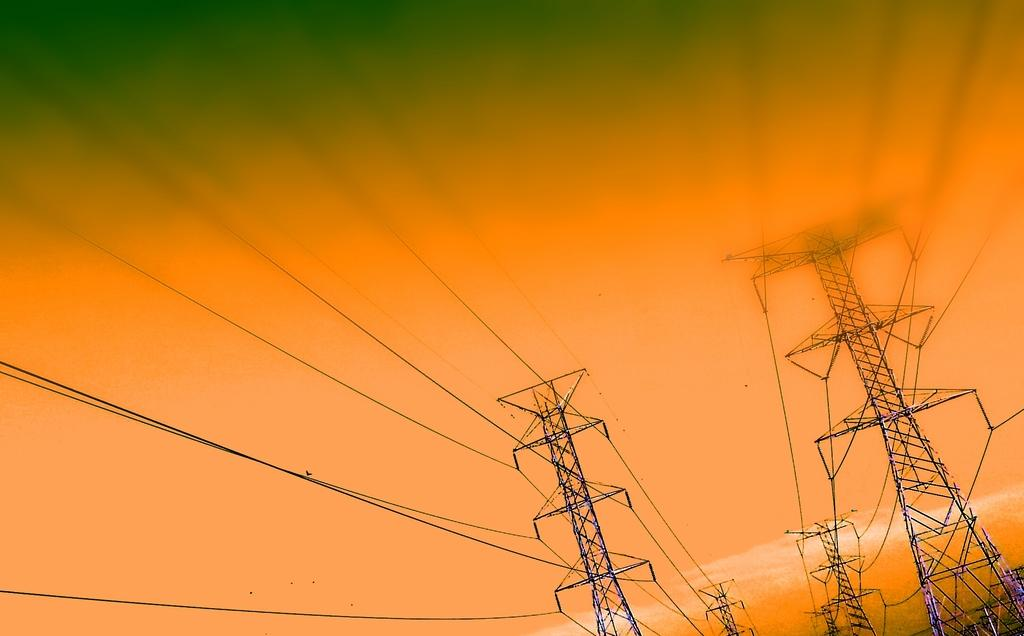What structures are present in the image? There are towers in the image. What else can be seen in the image besides the towers? There are wires in the image. What is visible in the background of the image? The sky is visible in the background of the image. What type of lawyer is depicted in the image? There is no lawyer present in the image; it features towers and wires. What time of day is it in the image, considering the presence of the rock? There is no rock present in the image, and therefore the time of day cannot be determined based on this object. 